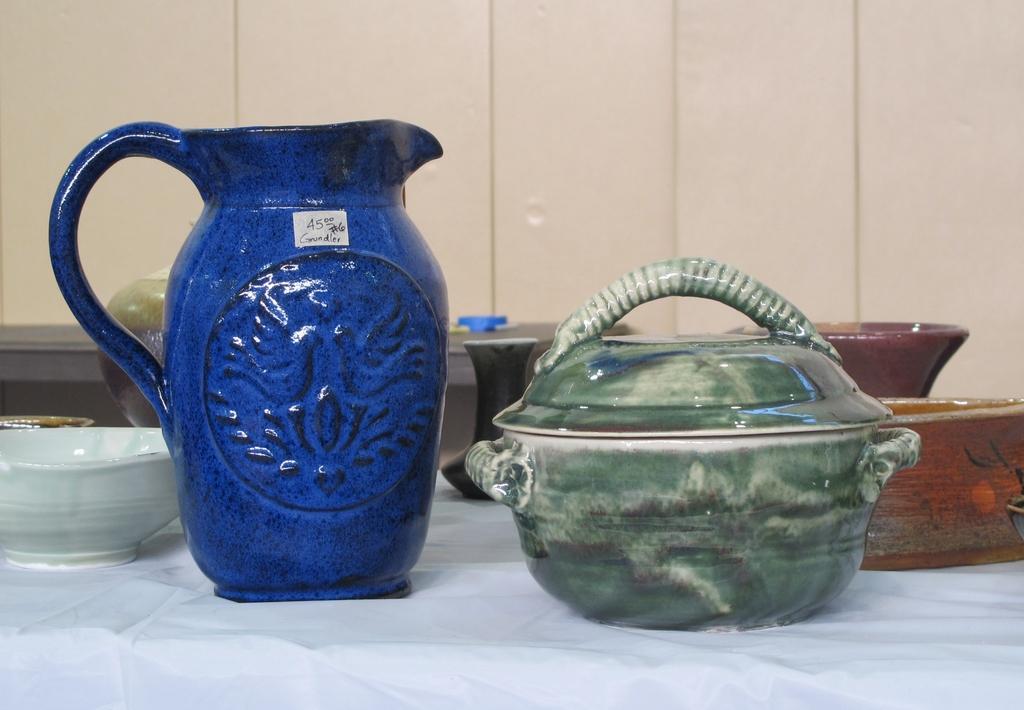Could you give a brief overview of what you see in this image? In this image in the foreground there are some pots and bowls, on the table and in the background there is another table and a wall. 